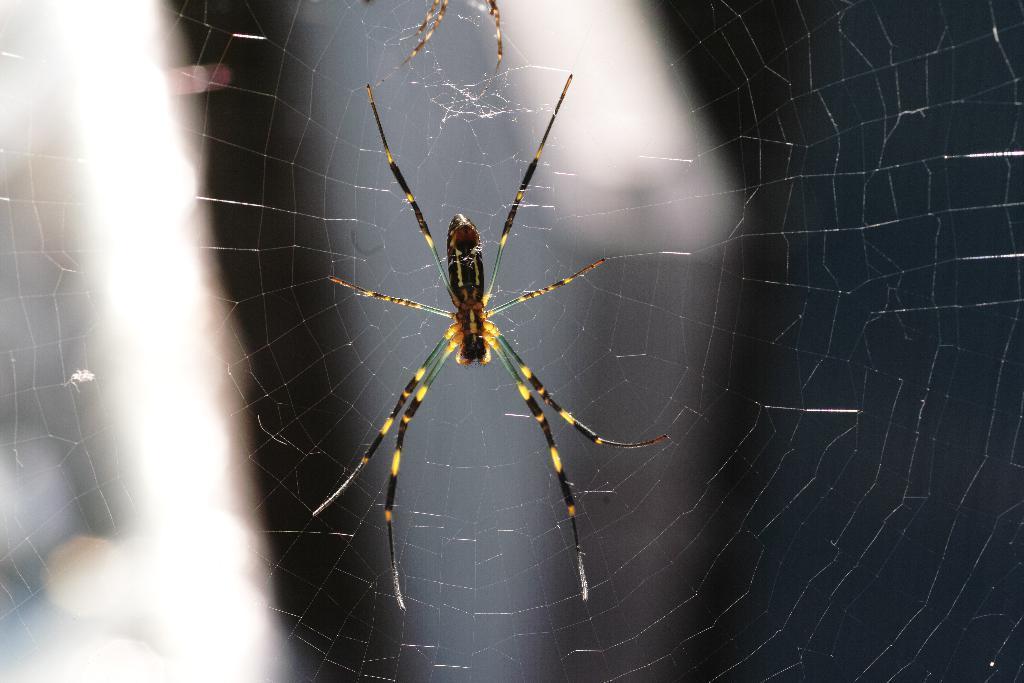How would you summarize this image in a sentence or two? In this image we can see there is a spider. 